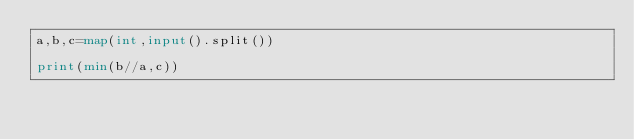<code> <loc_0><loc_0><loc_500><loc_500><_Python_>a,b,c=map(int,input().split())

print(min(b//a,c))
</code> 